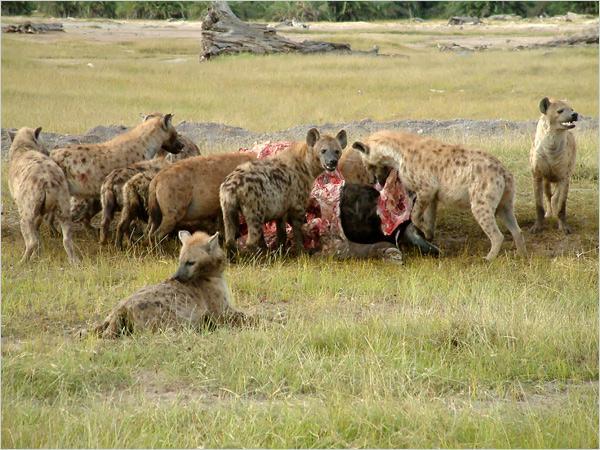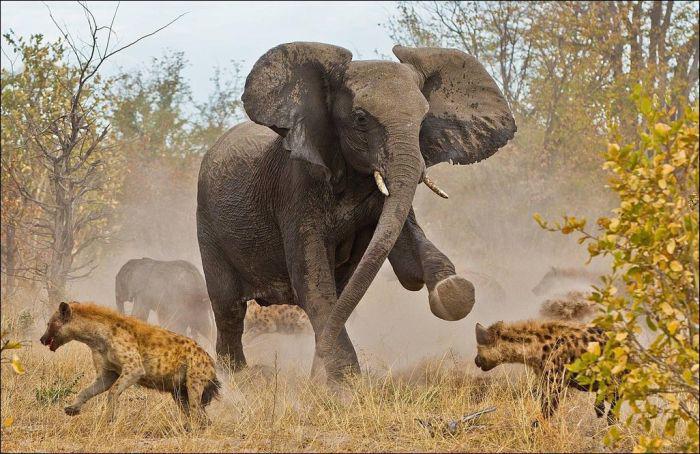The first image is the image on the left, the second image is the image on the right. Considering the images on both sides, is "There is an elephant among hyenas in one of the images." valid? Answer yes or no. Yes. The first image is the image on the left, the second image is the image on the right. Examine the images to the left and right. Is the description "An elephant with tusks is running near a hyena." accurate? Answer yes or no. Yes. 